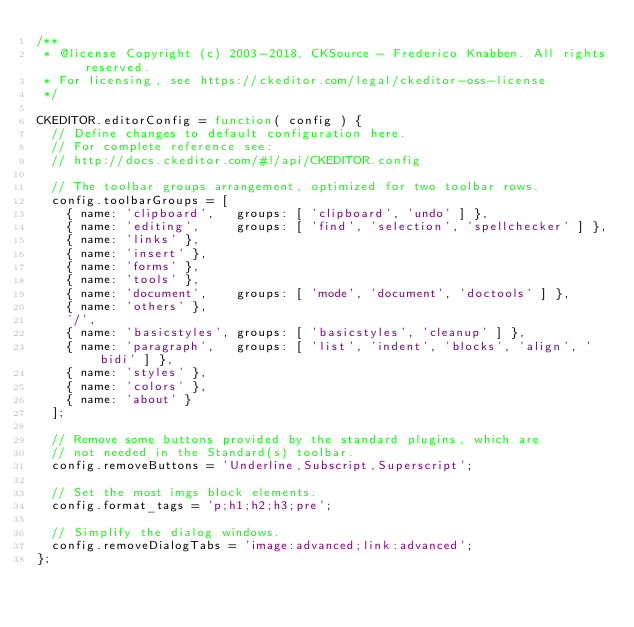Convert code to text. <code><loc_0><loc_0><loc_500><loc_500><_JavaScript_>/**
 * @license Copyright (c) 2003-2018, CKSource - Frederico Knabben. All rights reserved.
 * For licensing, see https://ckeditor.com/legal/ckeditor-oss-license
 */

CKEDITOR.editorConfig = function( config ) {
	// Define changes to default configuration here.
	// For complete reference see:
	// http://docs.ckeditor.com/#!/api/CKEDITOR.config

	// The toolbar groups arrangement, optimized for two toolbar rows.
	config.toolbarGroups = [
		{ name: 'clipboard',   groups: [ 'clipboard', 'undo' ] },
		{ name: 'editing',     groups: [ 'find', 'selection', 'spellchecker' ] },
		{ name: 'links' },
		{ name: 'insert' },
		{ name: 'forms' },
		{ name: 'tools' },
		{ name: 'document',	   groups: [ 'mode', 'document', 'doctools' ] },
		{ name: 'others' },
		'/',
		{ name: 'basicstyles', groups: [ 'basicstyles', 'cleanup' ] },
		{ name: 'paragraph',   groups: [ 'list', 'indent', 'blocks', 'align', 'bidi' ] },
		{ name: 'styles' },
		{ name: 'colors' },
		{ name: 'about' }
	];

	// Remove some buttons provided by the standard plugins, which are
	// not needed in the Standard(s) toolbar.
	config.removeButtons = 'Underline,Subscript,Superscript';

	// Set the most imgs block elements.
	config.format_tags = 'p;h1;h2;h3;pre';

	// Simplify the dialog windows.
	config.removeDialogTabs = 'image:advanced;link:advanced';
};
</code> 